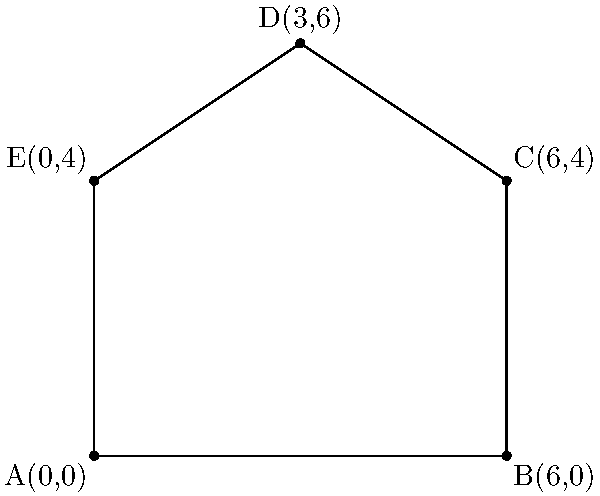As a pet-themed illustrator, you're designing an irregularly shaped pet bed. The bed's outline is represented on a coordinate plane by the points A(0,0), B(6,0), C(6,4), D(3,6), and E(0,4), forming a closed shape. Calculate the area of this pet bed design. To find the area of this irregular shape, we can divide it into simpler shapes and sum their areas:

1) Divide the shape into a rectangle (ABCE) and a triangle (CDE).

2) Calculate the area of rectangle ABCE:
   Width = 6 units (from A to B)
   Height = 4 units (from A to E)
   Area of rectangle = $6 * 4 = 24$ square units

3) Calculate the area of triangle CDE:
   Base = 6 units (from E to C)
   Height = 2 units (from D to EC)
   Area of triangle = $\frac{1}{2} * 6 * 2 = 6$ square units

4) Sum the areas:
   Total Area = Area of rectangle + Area of triangle
               = $24 + 6 = 30$ square units

Therefore, the area of the pet bed design is 30 square units.
Answer: $30$ square units 